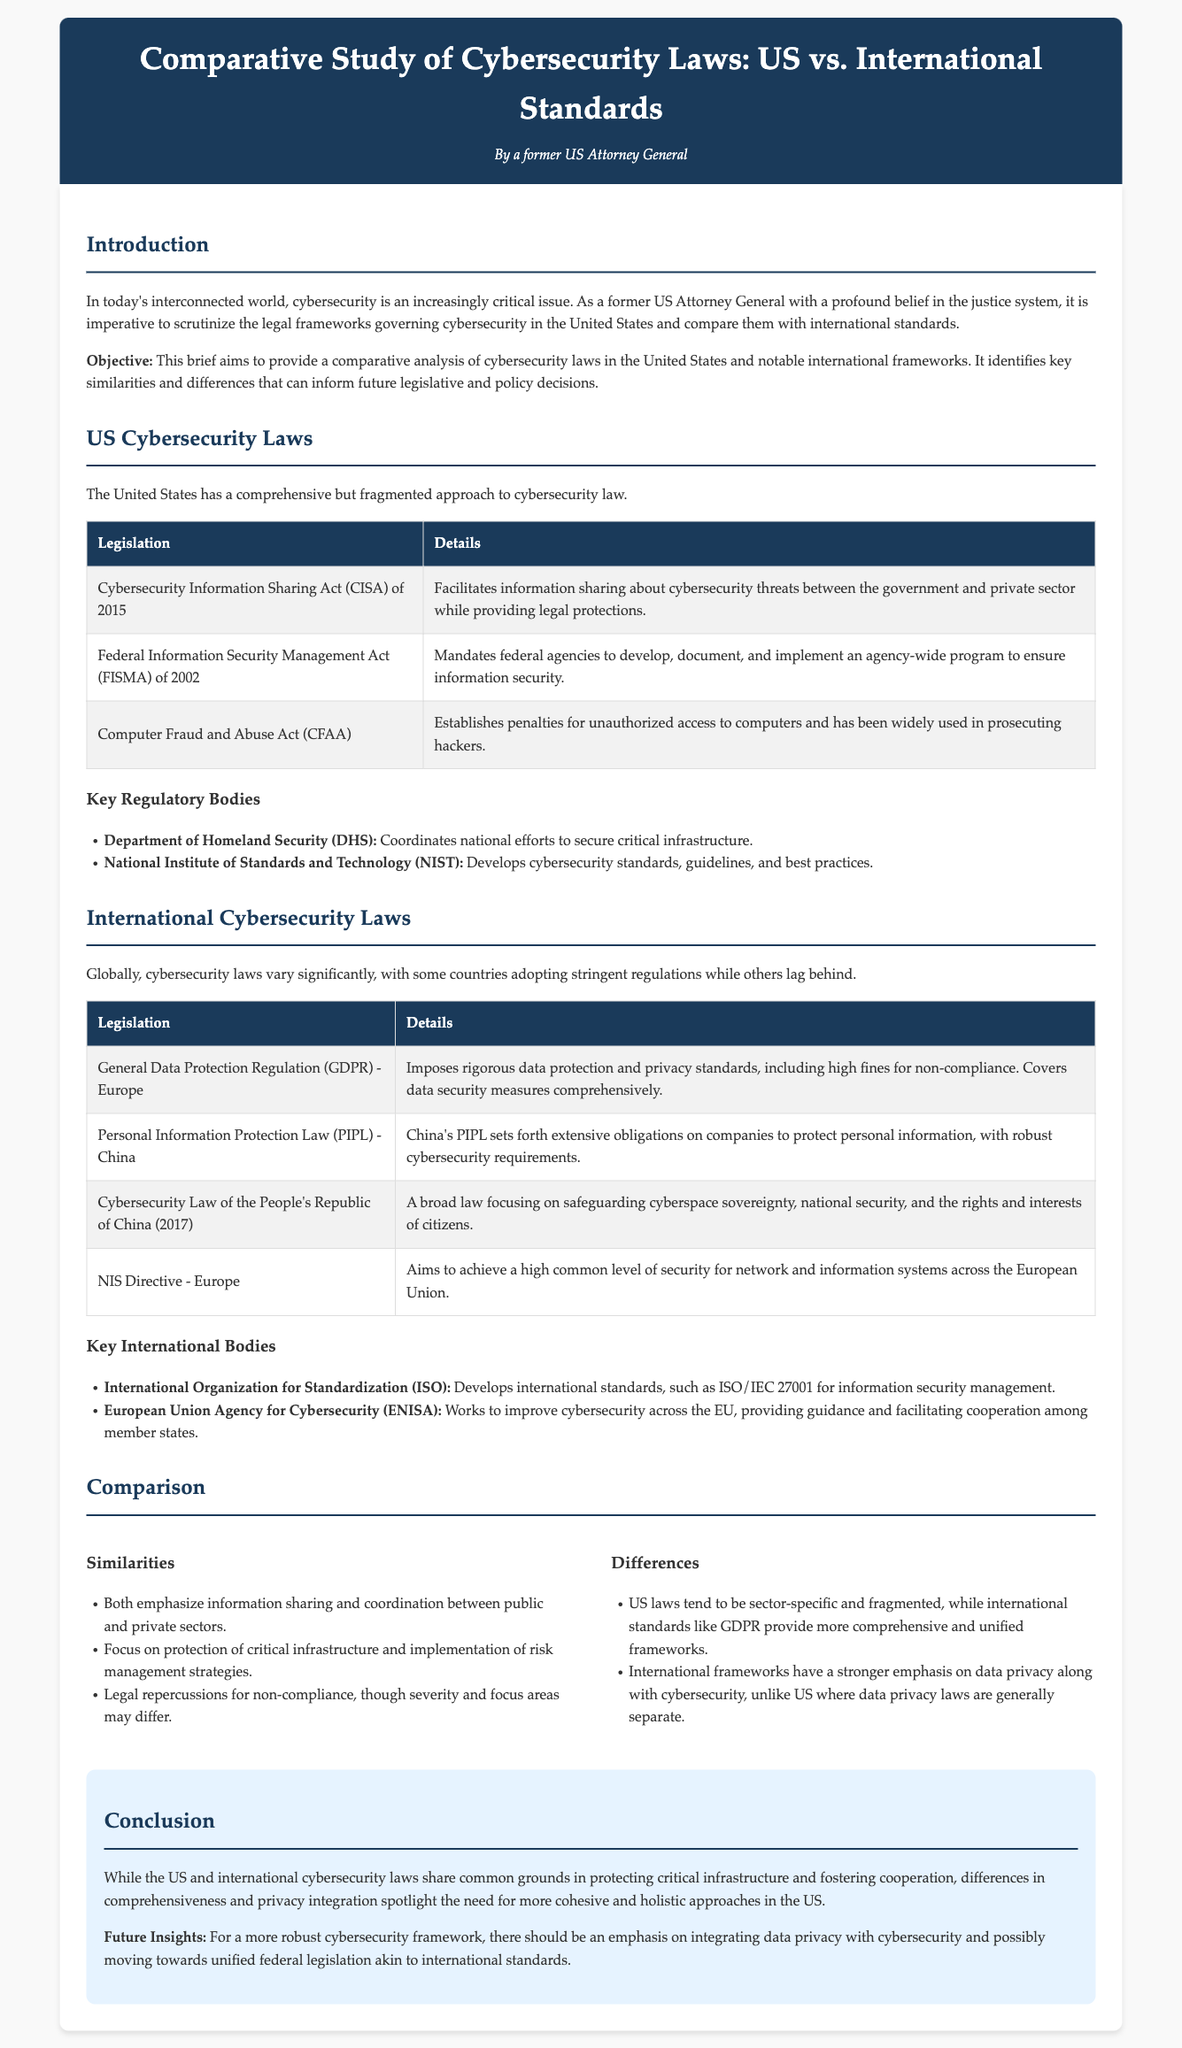what is the title of the document? The title of the document is found in the header section, indicating the main topic being explored.
Answer: Comparative Study of Cybersecurity Laws: US vs. International Standards what year was the Cybersecurity Information Sharing Act enacted? The enactment year can be extracted from the table of US Cybersecurity Laws provided in the document.
Answer: 2015 what does GDPR stand for? The abbreviation for the General Data Protection Regulation is explained in the section discussing International Cybersecurity Laws.
Answer: General Data Protection Regulation which US regulatory body coordinates national efforts to secure critical infrastructure? This information is found in the list of key regulatory bodies under US Cybersecurity Laws.
Answer: Department of Homeland Security what is one similarity between US and international cybersecurity laws? A similarity can be found in the comparison section where key points are highlighted regarding both US and international laws.
Answer: Emphasis on information sharing what is a major difference between US cybersecurity laws and international standards? The differences are specified in the comparison section under the differences category, indicating the nature of legal frameworks.
Answer: US laws tend to be sector-specific and fragmented who is responsible for developing international standards for information security management? The responsible organization is mentioned in the key international bodies section of the document.
Answer: International Organization for Standardization what is the key focus of the NIS Directive in Europe? The focus of the NIS Directive is stated in the section describing international cybersecurity laws and regulations.
Answer: High common level of security for network and information systems 